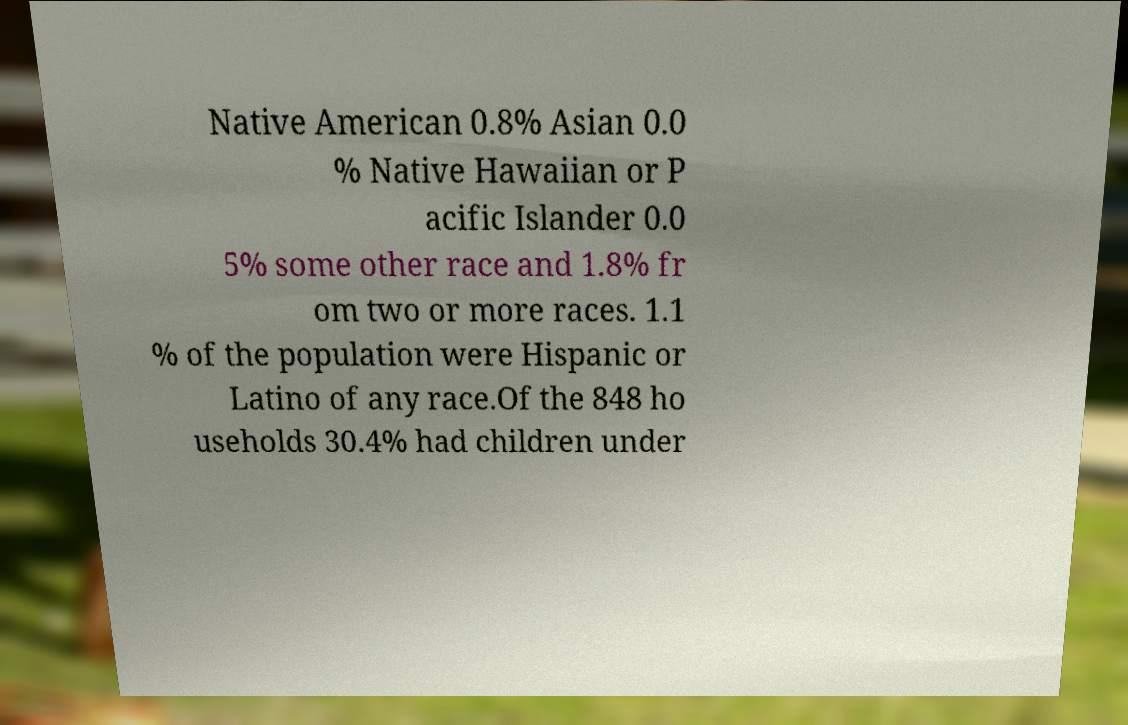I need the written content from this picture converted into text. Can you do that? Native American 0.8% Asian 0.0 % Native Hawaiian or P acific Islander 0.0 5% some other race and 1.8% fr om two or more races. 1.1 % of the population were Hispanic or Latino of any race.Of the 848 ho useholds 30.4% had children under 